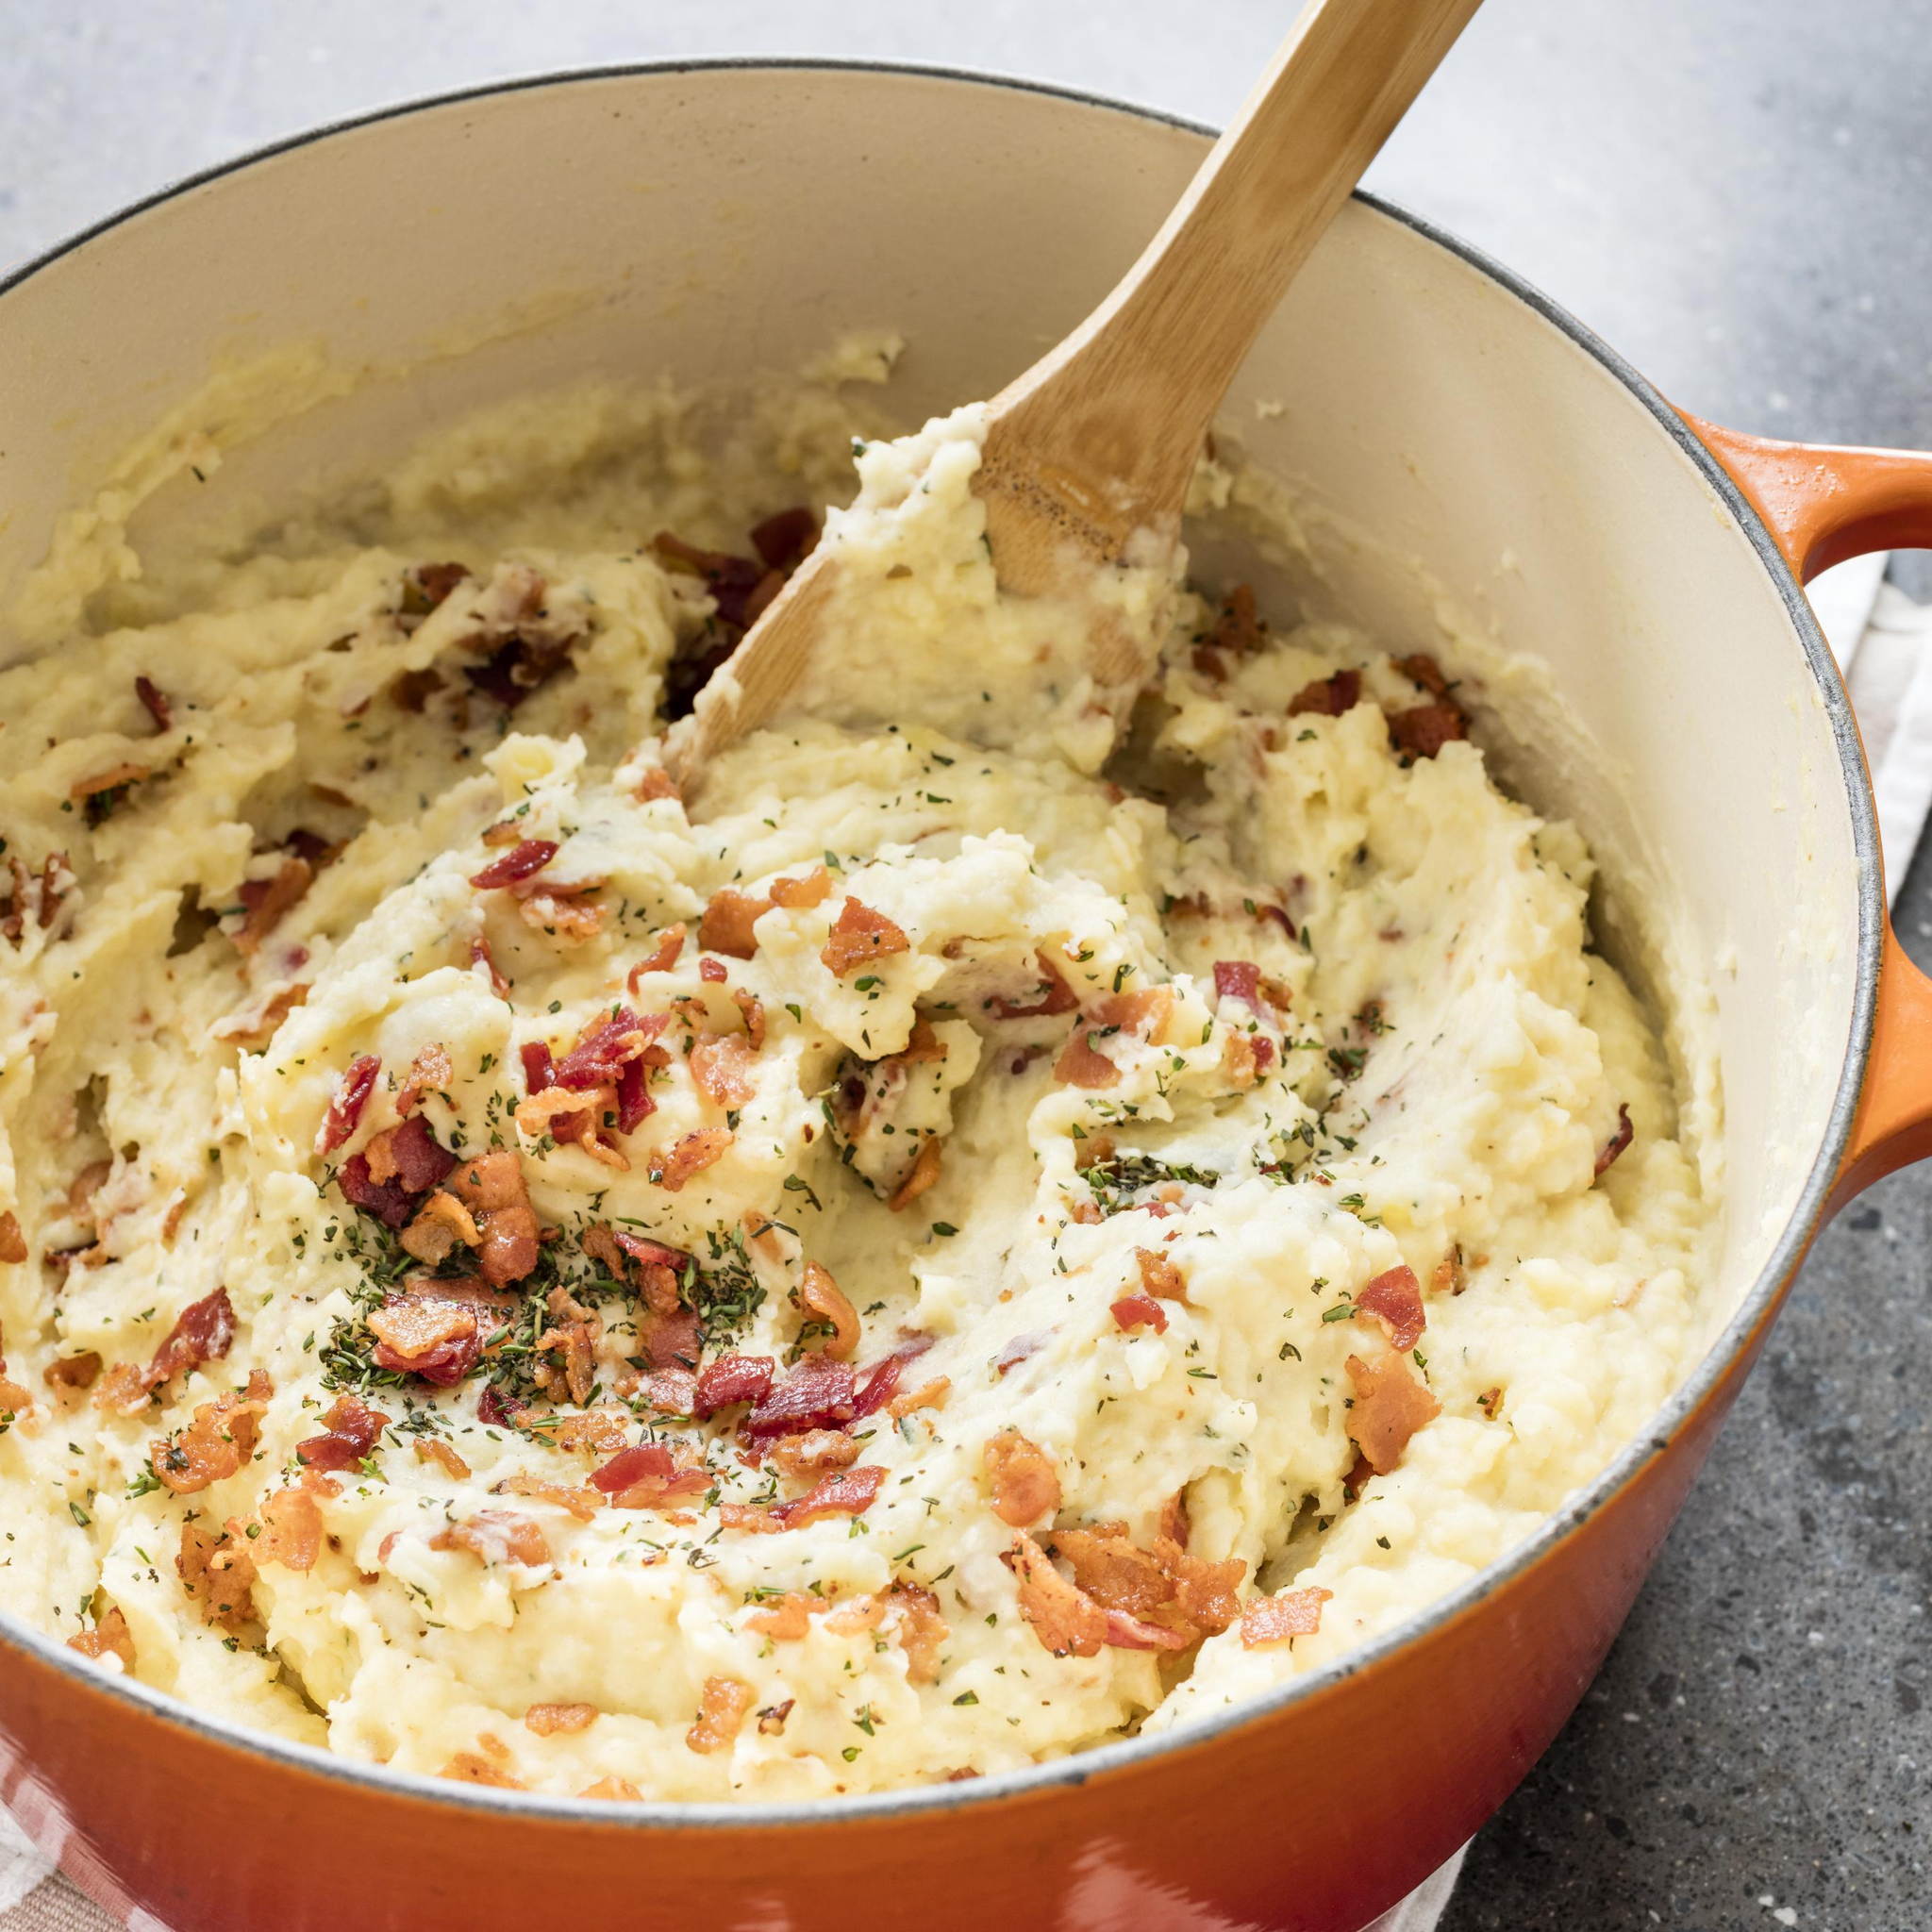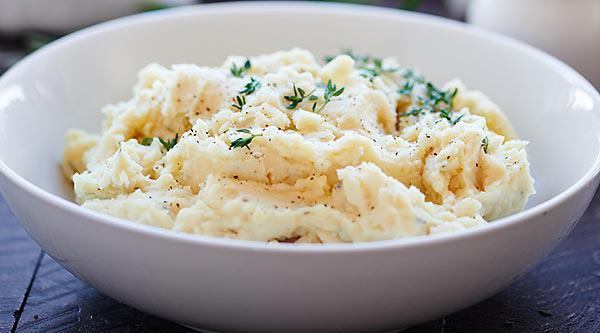The first image is the image on the left, the second image is the image on the right. Assess this claim about the two images: "Each image shows mashed potatoes on a round white dish, at least one image shows brown broth over the potatoes, and a piece of silverware is to the right of one dish.". Correct or not? Answer yes or no. No. The first image is the image on the left, the second image is the image on the right. Examine the images to the left and right. Is the description "In one image, brown gravy and a spring of chive are on mashed potatoes in a white bowl." accurate? Answer yes or no. No. 